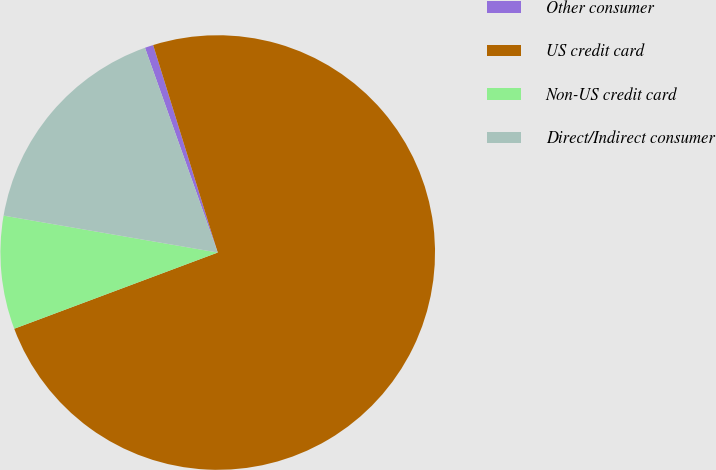<chart> <loc_0><loc_0><loc_500><loc_500><pie_chart><fcel>Other consumer<fcel>US credit card<fcel>Non-US credit card<fcel>Direct/Indirect consumer<nl><fcel>0.63%<fcel>74.1%<fcel>8.42%<fcel>16.85%<nl></chart> 